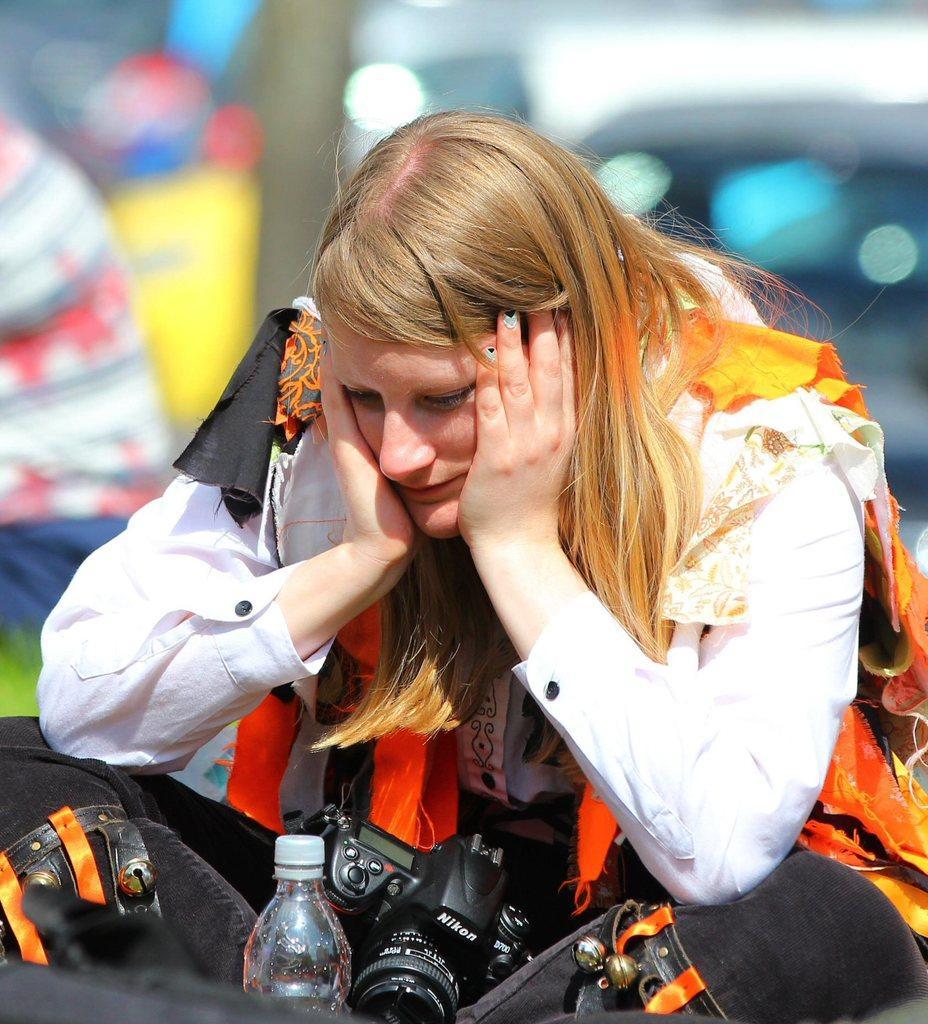Can you describe this image briefly? In this picture a woman is wearing a camera and she has a water bottle in front of her she is staring at the water bottle. 